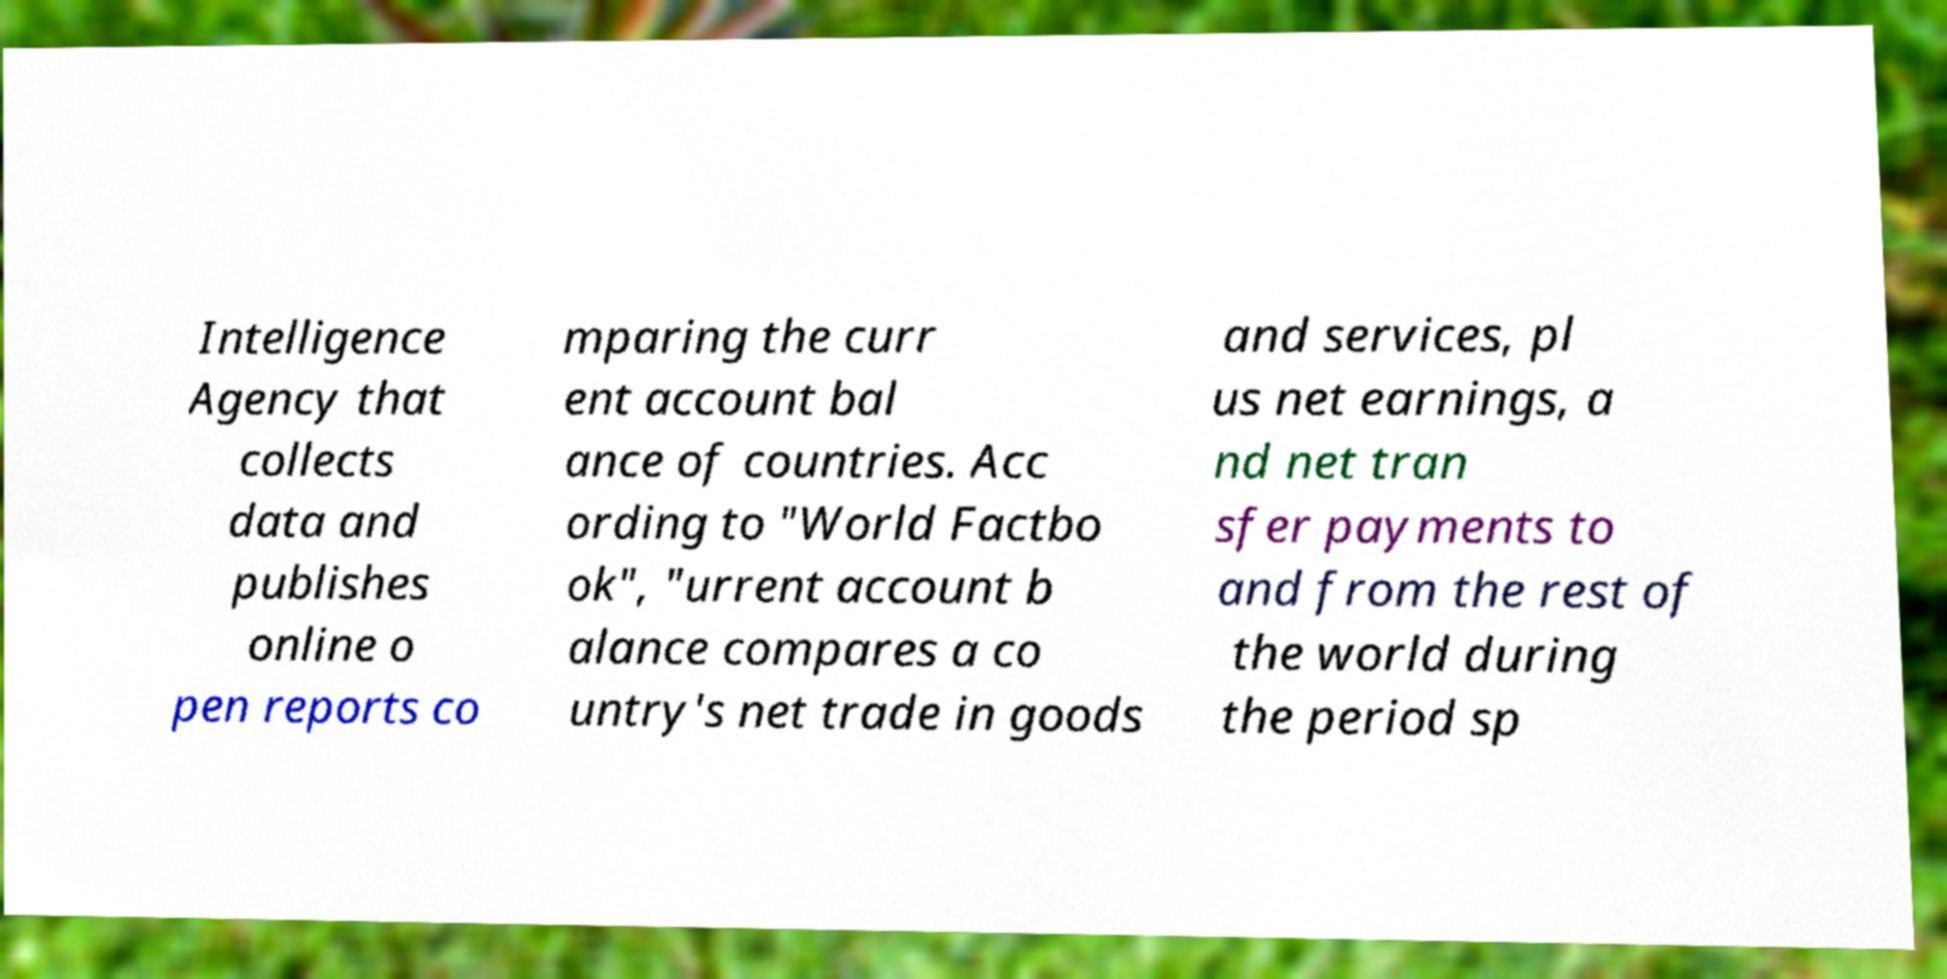I need the written content from this picture converted into text. Can you do that? Intelligence Agency that collects data and publishes online o pen reports co mparing the curr ent account bal ance of countries. Acc ording to "World Factbo ok", "urrent account b alance compares a co untry's net trade in goods and services, pl us net earnings, a nd net tran sfer payments to and from the rest of the world during the period sp 